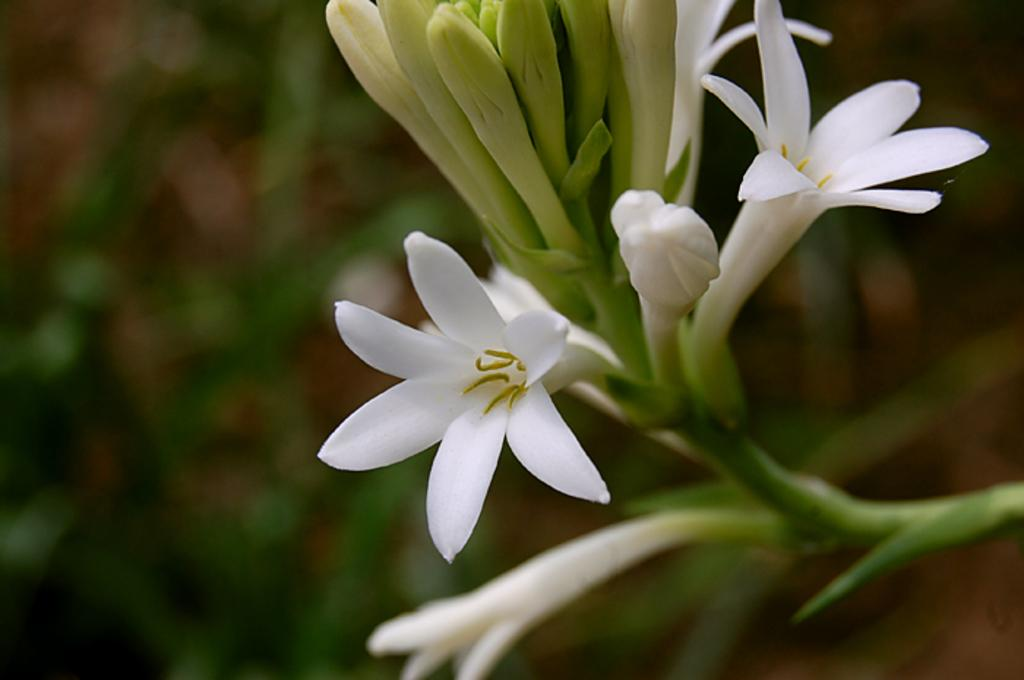What type of flowers are visible in the image? There are white flowers on a stem in the image. Are there any unopened flowers on the stem? Yes, there are buds on the stem. How would you describe the background of the image? The background of the image is blurred. What flavor of song can be heard playing in the background of the image? There is no song or sound present in the image, so it is not possible to determine the flavor of a song. 